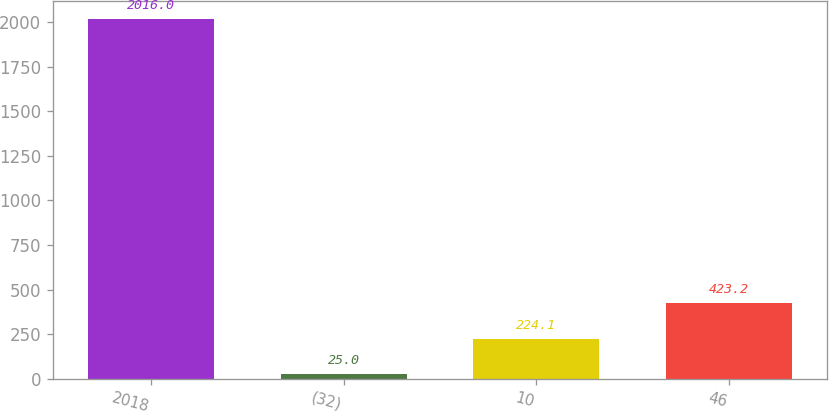Convert chart. <chart><loc_0><loc_0><loc_500><loc_500><bar_chart><fcel>2018<fcel>(32)<fcel>10<fcel>46<nl><fcel>2016<fcel>25<fcel>224.1<fcel>423.2<nl></chart> 